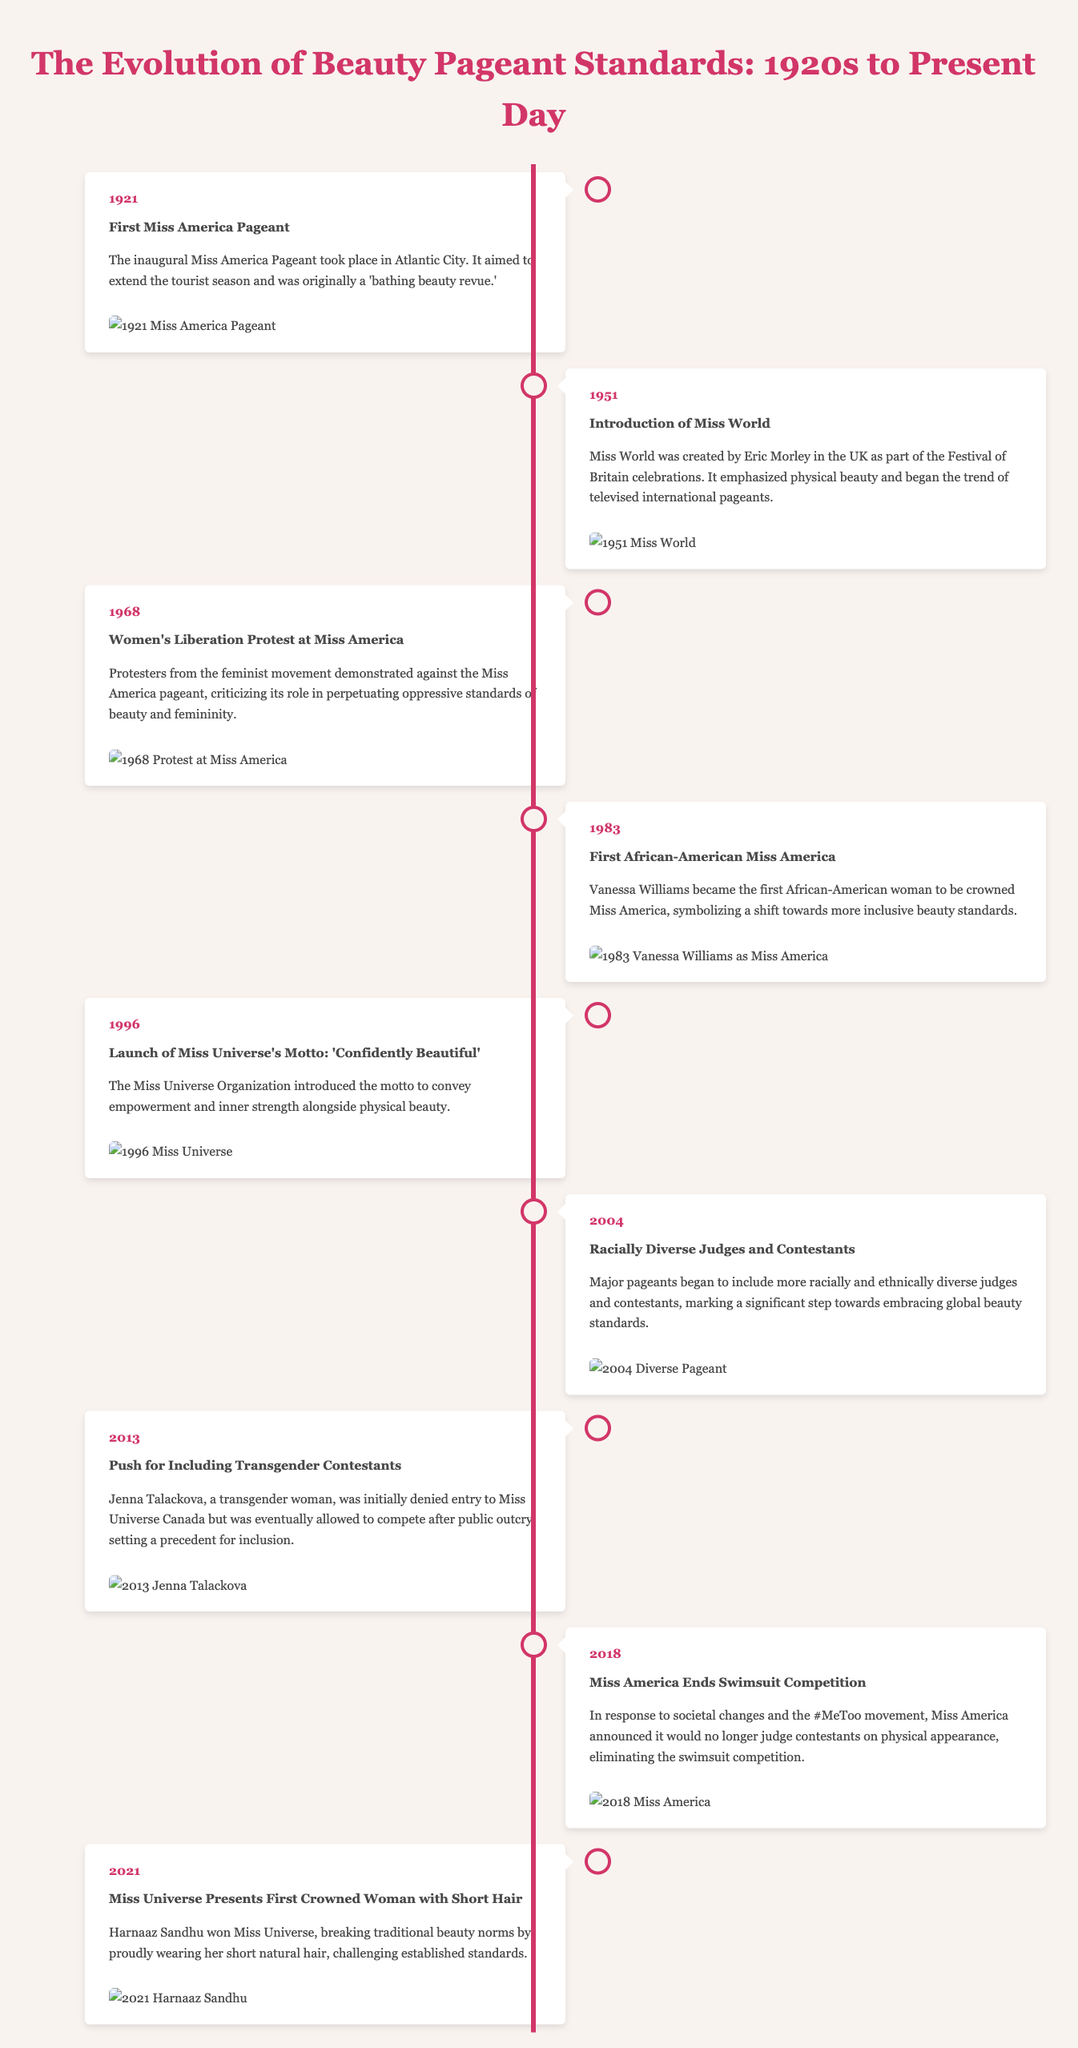What year was the first Miss America Pageant held? The document states that the first Miss America Pageant took place in 1921.
Answer: 1921 Who became the first African-American Miss America? The document mentions that Vanessa Williams was the first African-American Miss America in 1983.
Answer: Vanessa Williams What major event took place in 1968 regarding the Miss America Pageant? According to the document, a Women's Liberation Protest occurred at the Miss America Pageant in 1968.
Answer: Women's Liberation Protest What was introduced as Miss Universe's motto in 1996? The document indicates that the motto 'Confidently Beautiful' was introduced by Miss Universe in 1996.
Answer: Confidently Beautiful In which year did the Miss America organization announce the end of the swimsuit competition? The document notes that the end of the swimsuit competition was announced in 2018.
Answer: 2018 What significant shift happened in beauty standards with Harnaaz Sandhu's win in 2021? The document highlights that Harnaaz Sandhu's win challenged traditional beauty norms by wearing short hair.
Answer: Short hair How did the Miss Universe competition change in 2013? The document details that in 2013, there was a push for including transgender contestants after Jenna Talackova's case.
Answer: Inclusion of transgender contestants Why did the Miss America Pageant face protests in 1968? The document shows that protests occurred due to criticisms of oppressive standards of beauty and femininity.
Answer: Oppressive standards of beauty What was a key feature of the Miss World pageant established in 1951? The document states that Miss World emphasized physical beauty and began the trend of televised international pageants.
Answer: Emphasized physical beauty 